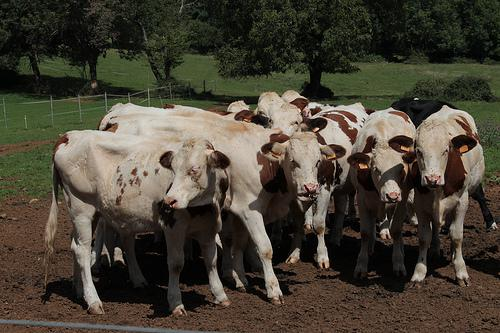Question: what is beneath the cows' feet?
Choices:
A. The ground.
B. Grass.
C. Rocks.
D. Dirt.
Answer with the letter. Answer: D Question: what is behind the cows?
Choices:
A. Trees.
B. Sky.
C. People.
D. More cows.
Answer with the letter. Answer: A Question: when was this picture taken?
Choices:
A. At night.
B. In the morning.
C. During the day.
D. At noon.
Answer with the letter. Answer: C 